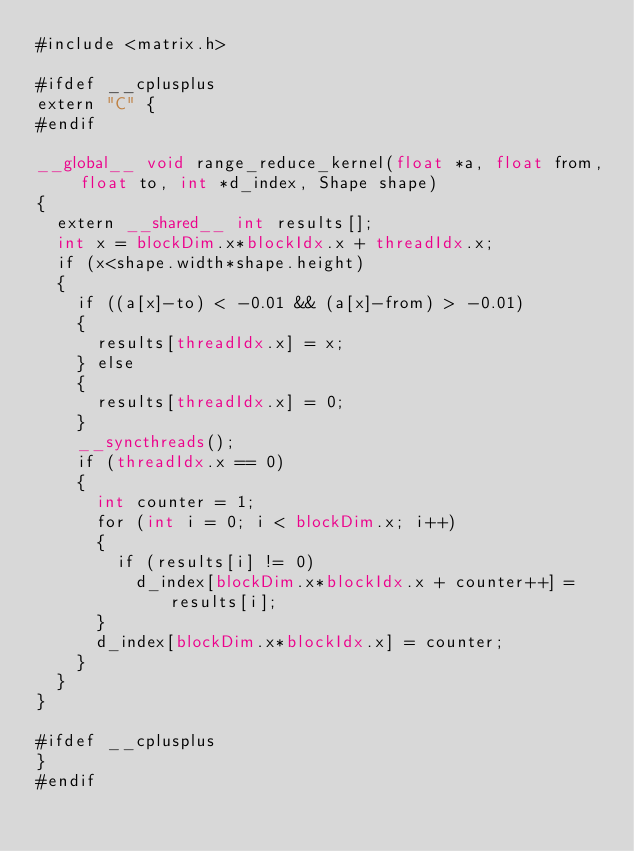Convert code to text. <code><loc_0><loc_0><loc_500><loc_500><_Cuda_>#include <matrix.h>

#ifdef __cplusplus
extern "C" {
#endif

__global__ void range_reduce_kernel(float *a, float from, float to, int *d_index, Shape shape)
{
  extern __shared__ int results[];
  int x = blockDim.x*blockIdx.x + threadIdx.x;
  if (x<shape.width*shape.height)
  {
    if ((a[x]-to) < -0.01 && (a[x]-from) > -0.01)
    {
      results[threadIdx.x] = x;
    } else
    {
      results[threadIdx.x] = 0;
    }
    __syncthreads();
    if (threadIdx.x == 0)
    {
      int counter = 1;
      for (int i = 0; i < blockDim.x; i++)
      {
        if (results[i] != 0)
          d_index[blockDim.x*blockIdx.x + counter++] = results[i];
      }
      d_index[blockDim.x*blockIdx.x] = counter;
    }
  }
}

#ifdef __cplusplus
}
#endif
</code> 